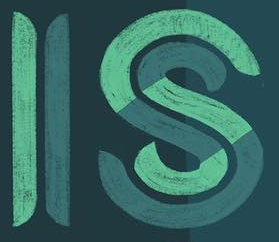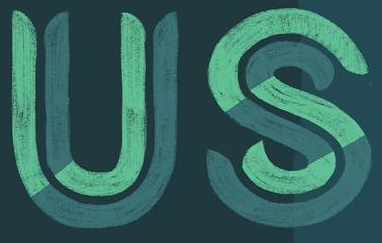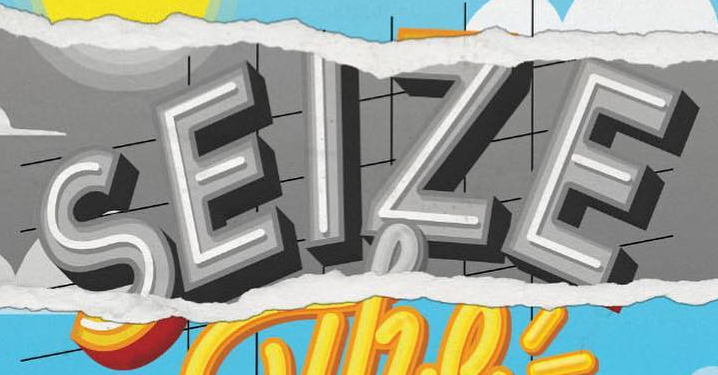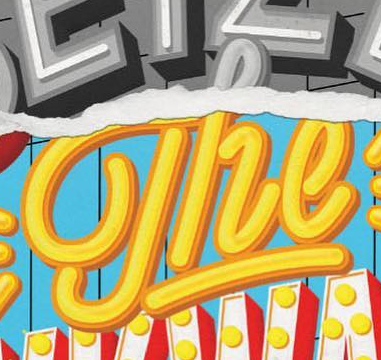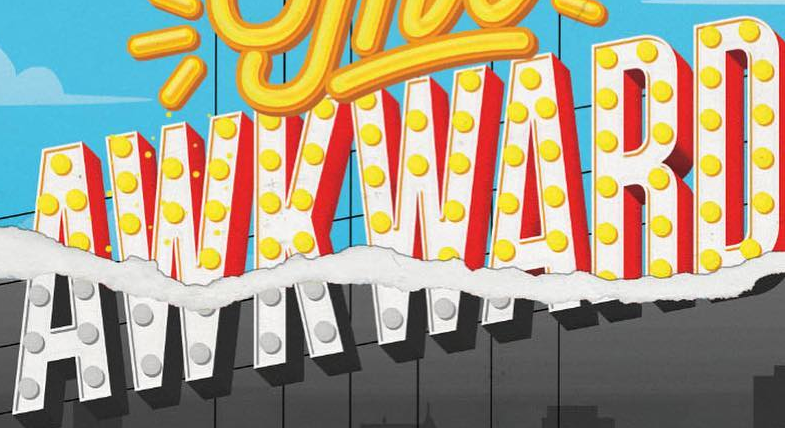Transcribe the words shown in these images in order, separated by a semicolon. IS; US; SEIZE; The; AWKWARD 